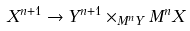Convert formula to latex. <formula><loc_0><loc_0><loc_500><loc_500>X ^ { n + 1 } \rightarrow Y ^ { n + 1 } \times _ { M ^ { n } Y } M ^ { n } X</formula> 